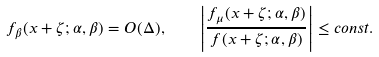Convert formula to latex. <formula><loc_0><loc_0><loc_500><loc_500>f _ { \beta } ( x + \zeta ; \alpha , \beta ) = O ( \Delta ) , \quad \left | \frac { f _ { \mu } ( x + \zeta ; \alpha , \beta ) } { f ( x + \zeta ; \alpha , \beta ) } \right | \leq c o n s t .</formula> 